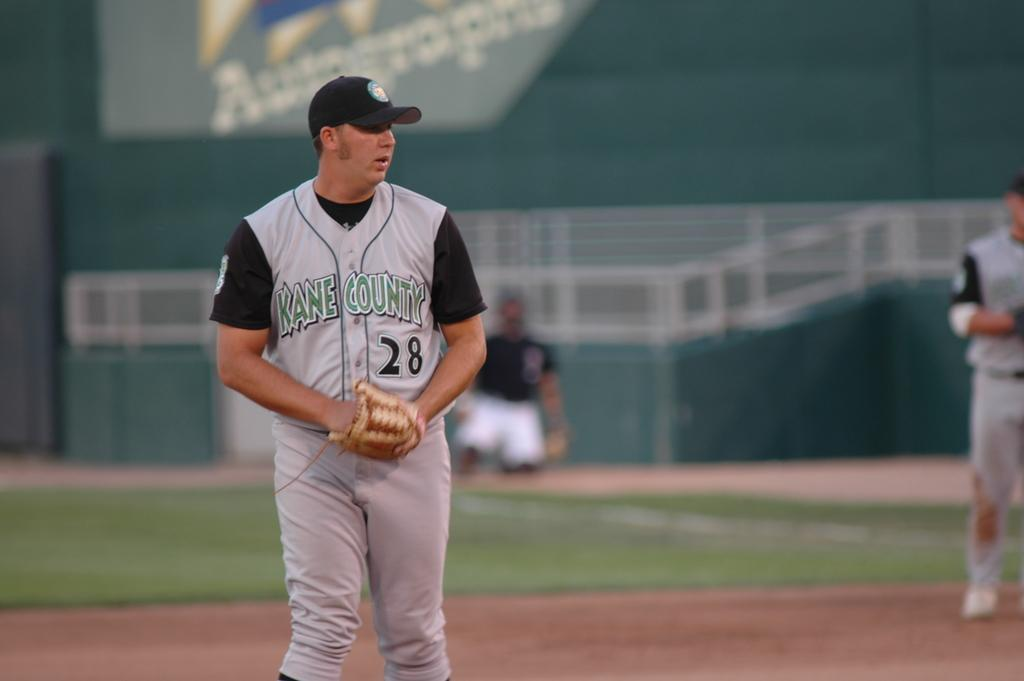Provide a one-sentence caption for the provided image. A pitcher from Kane County on a baseball field. 